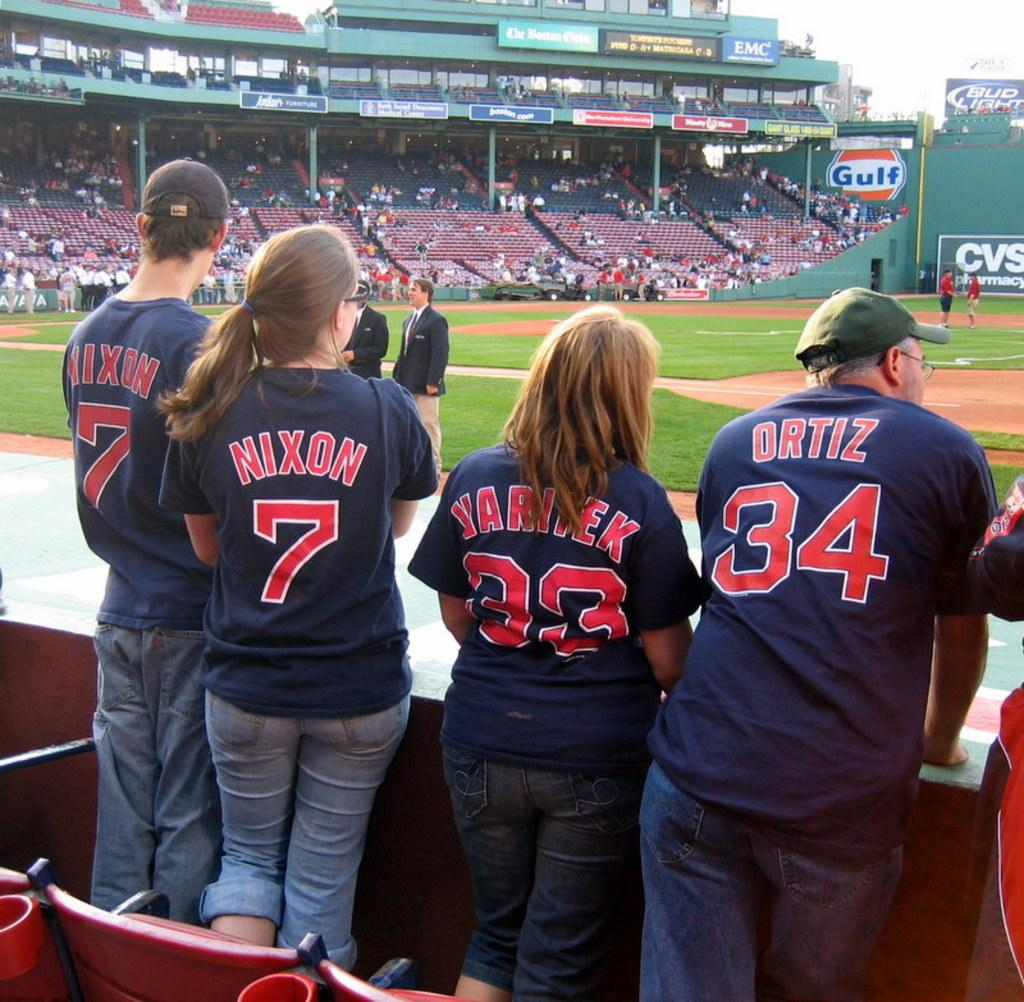Provide a one-sentence caption for the provided image. Four people wear shirts with numbers 7, 7, 33 and 34. 